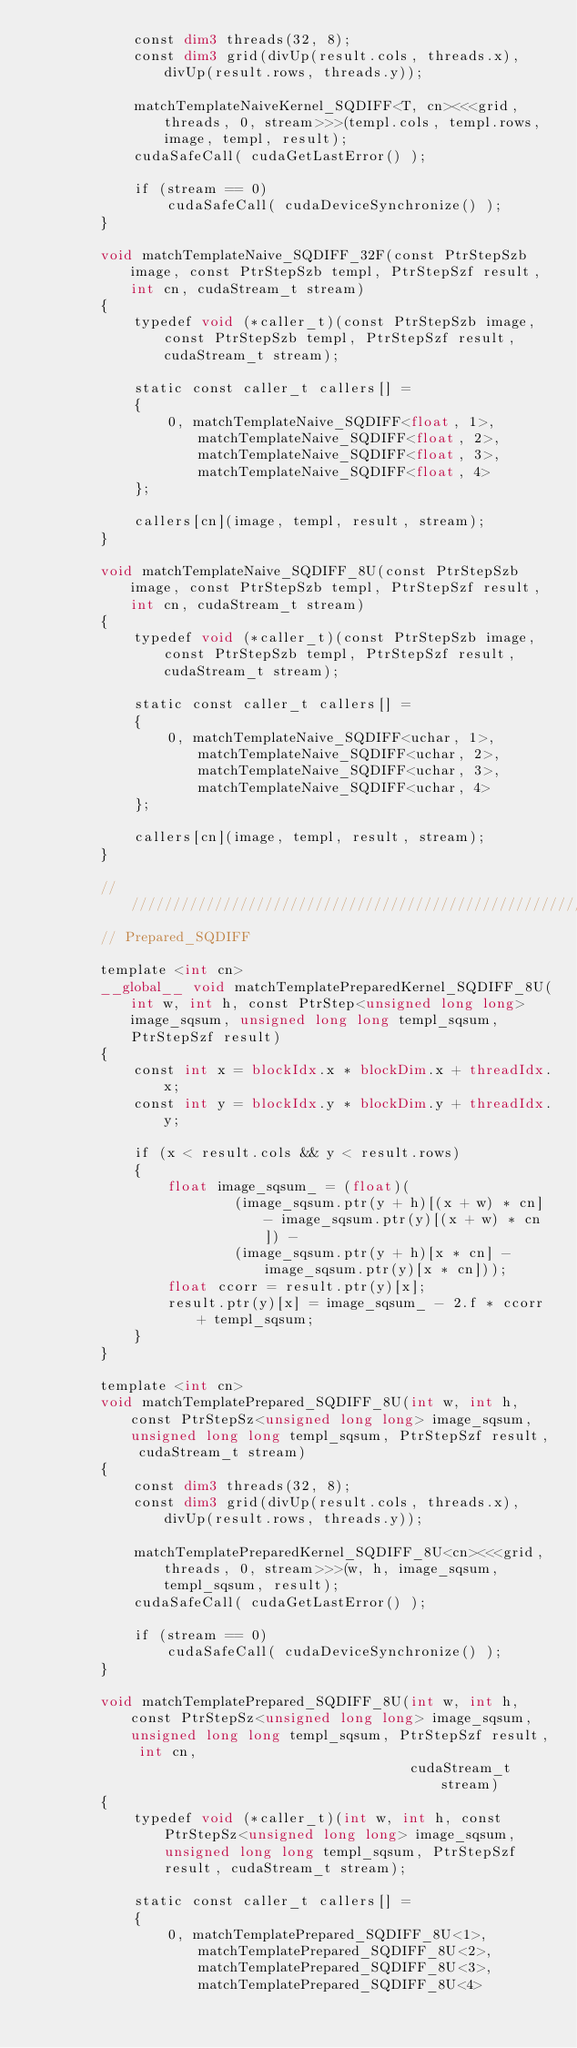Convert code to text. <code><loc_0><loc_0><loc_500><loc_500><_Cuda_>            const dim3 threads(32, 8);
            const dim3 grid(divUp(result.cols, threads.x), divUp(result.rows, threads.y));

            matchTemplateNaiveKernel_SQDIFF<T, cn><<<grid, threads, 0, stream>>>(templ.cols, templ.rows, image, templ, result);
            cudaSafeCall( cudaGetLastError() );

            if (stream == 0)
                cudaSafeCall( cudaDeviceSynchronize() );
        }

        void matchTemplateNaive_SQDIFF_32F(const PtrStepSzb image, const PtrStepSzb templ, PtrStepSzf result, int cn, cudaStream_t stream)
        {
            typedef void (*caller_t)(const PtrStepSzb image, const PtrStepSzb templ, PtrStepSzf result, cudaStream_t stream);

            static const caller_t callers[] =
            {
                0, matchTemplateNaive_SQDIFF<float, 1>, matchTemplateNaive_SQDIFF<float, 2>, matchTemplateNaive_SQDIFF<float, 3>, matchTemplateNaive_SQDIFF<float, 4>
            };

            callers[cn](image, templ, result, stream);
        }

        void matchTemplateNaive_SQDIFF_8U(const PtrStepSzb image, const PtrStepSzb templ, PtrStepSzf result, int cn, cudaStream_t stream)
        {
            typedef void (*caller_t)(const PtrStepSzb image, const PtrStepSzb templ, PtrStepSzf result, cudaStream_t stream);

            static const caller_t callers[] =
            {
                0, matchTemplateNaive_SQDIFF<uchar, 1>, matchTemplateNaive_SQDIFF<uchar, 2>, matchTemplateNaive_SQDIFF<uchar, 3>, matchTemplateNaive_SQDIFF<uchar, 4>
            };

            callers[cn](image, templ, result, stream);
        }

        //////////////////////////////////////////////////////////////////////
        // Prepared_SQDIFF

        template <int cn>
        __global__ void matchTemplatePreparedKernel_SQDIFF_8U(int w, int h, const PtrStep<unsigned long long> image_sqsum, unsigned long long templ_sqsum, PtrStepSzf result)
        {
            const int x = blockIdx.x * blockDim.x + threadIdx.x;
            const int y = blockIdx.y * blockDim.y + threadIdx.y;

            if (x < result.cols && y < result.rows)
            {
                float image_sqsum_ = (float)(
                        (image_sqsum.ptr(y + h)[(x + w) * cn] - image_sqsum.ptr(y)[(x + w) * cn]) -
                        (image_sqsum.ptr(y + h)[x * cn] - image_sqsum.ptr(y)[x * cn]));
                float ccorr = result.ptr(y)[x];
                result.ptr(y)[x] = image_sqsum_ - 2.f * ccorr + templ_sqsum;
            }
        }

        template <int cn>
        void matchTemplatePrepared_SQDIFF_8U(int w, int h, const PtrStepSz<unsigned long long> image_sqsum, unsigned long long templ_sqsum, PtrStepSzf result, cudaStream_t stream)
        {
            const dim3 threads(32, 8);
            const dim3 grid(divUp(result.cols, threads.x), divUp(result.rows, threads.y));

            matchTemplatePreparedKernel_SQDIFF_8U<cn><<<grid, threads, 0, stream>>>(w, h, image_sqsum, templ_sqsum, result);
            cudaSafeCall( cudaGetLastError() );

            if (stream == 0)
                cudaSafeCall( cudaDeviceSynchronize() );
        }

        void matchTemplatePrepared_SQDIFF_8U(int w, int h, const PtrStepSz<unsigned long long> image_sqsum, unsigned long long templ_sqsum, PtrStepSzf result, int cn,
                                             cudaStream_t stream)
        {
            typedef void (*caller_t)(int w, int h, const PtrStepSz<unsigned long long> image_sqsum, unsigned long long templ_sqsum, PtrStepSzf result, cudaStream_t stream);

            static const caller_t callers[] =
            {
                0, matchTemplatePrepared_SQDIFF_8U<1>, matchTemplatePrepared_SQDIFF_8U<2>, matchTemplatePrepared_SQDIFF_8U<3>, matchTemplatePrepared_SQDIFF_8U<4></code> 